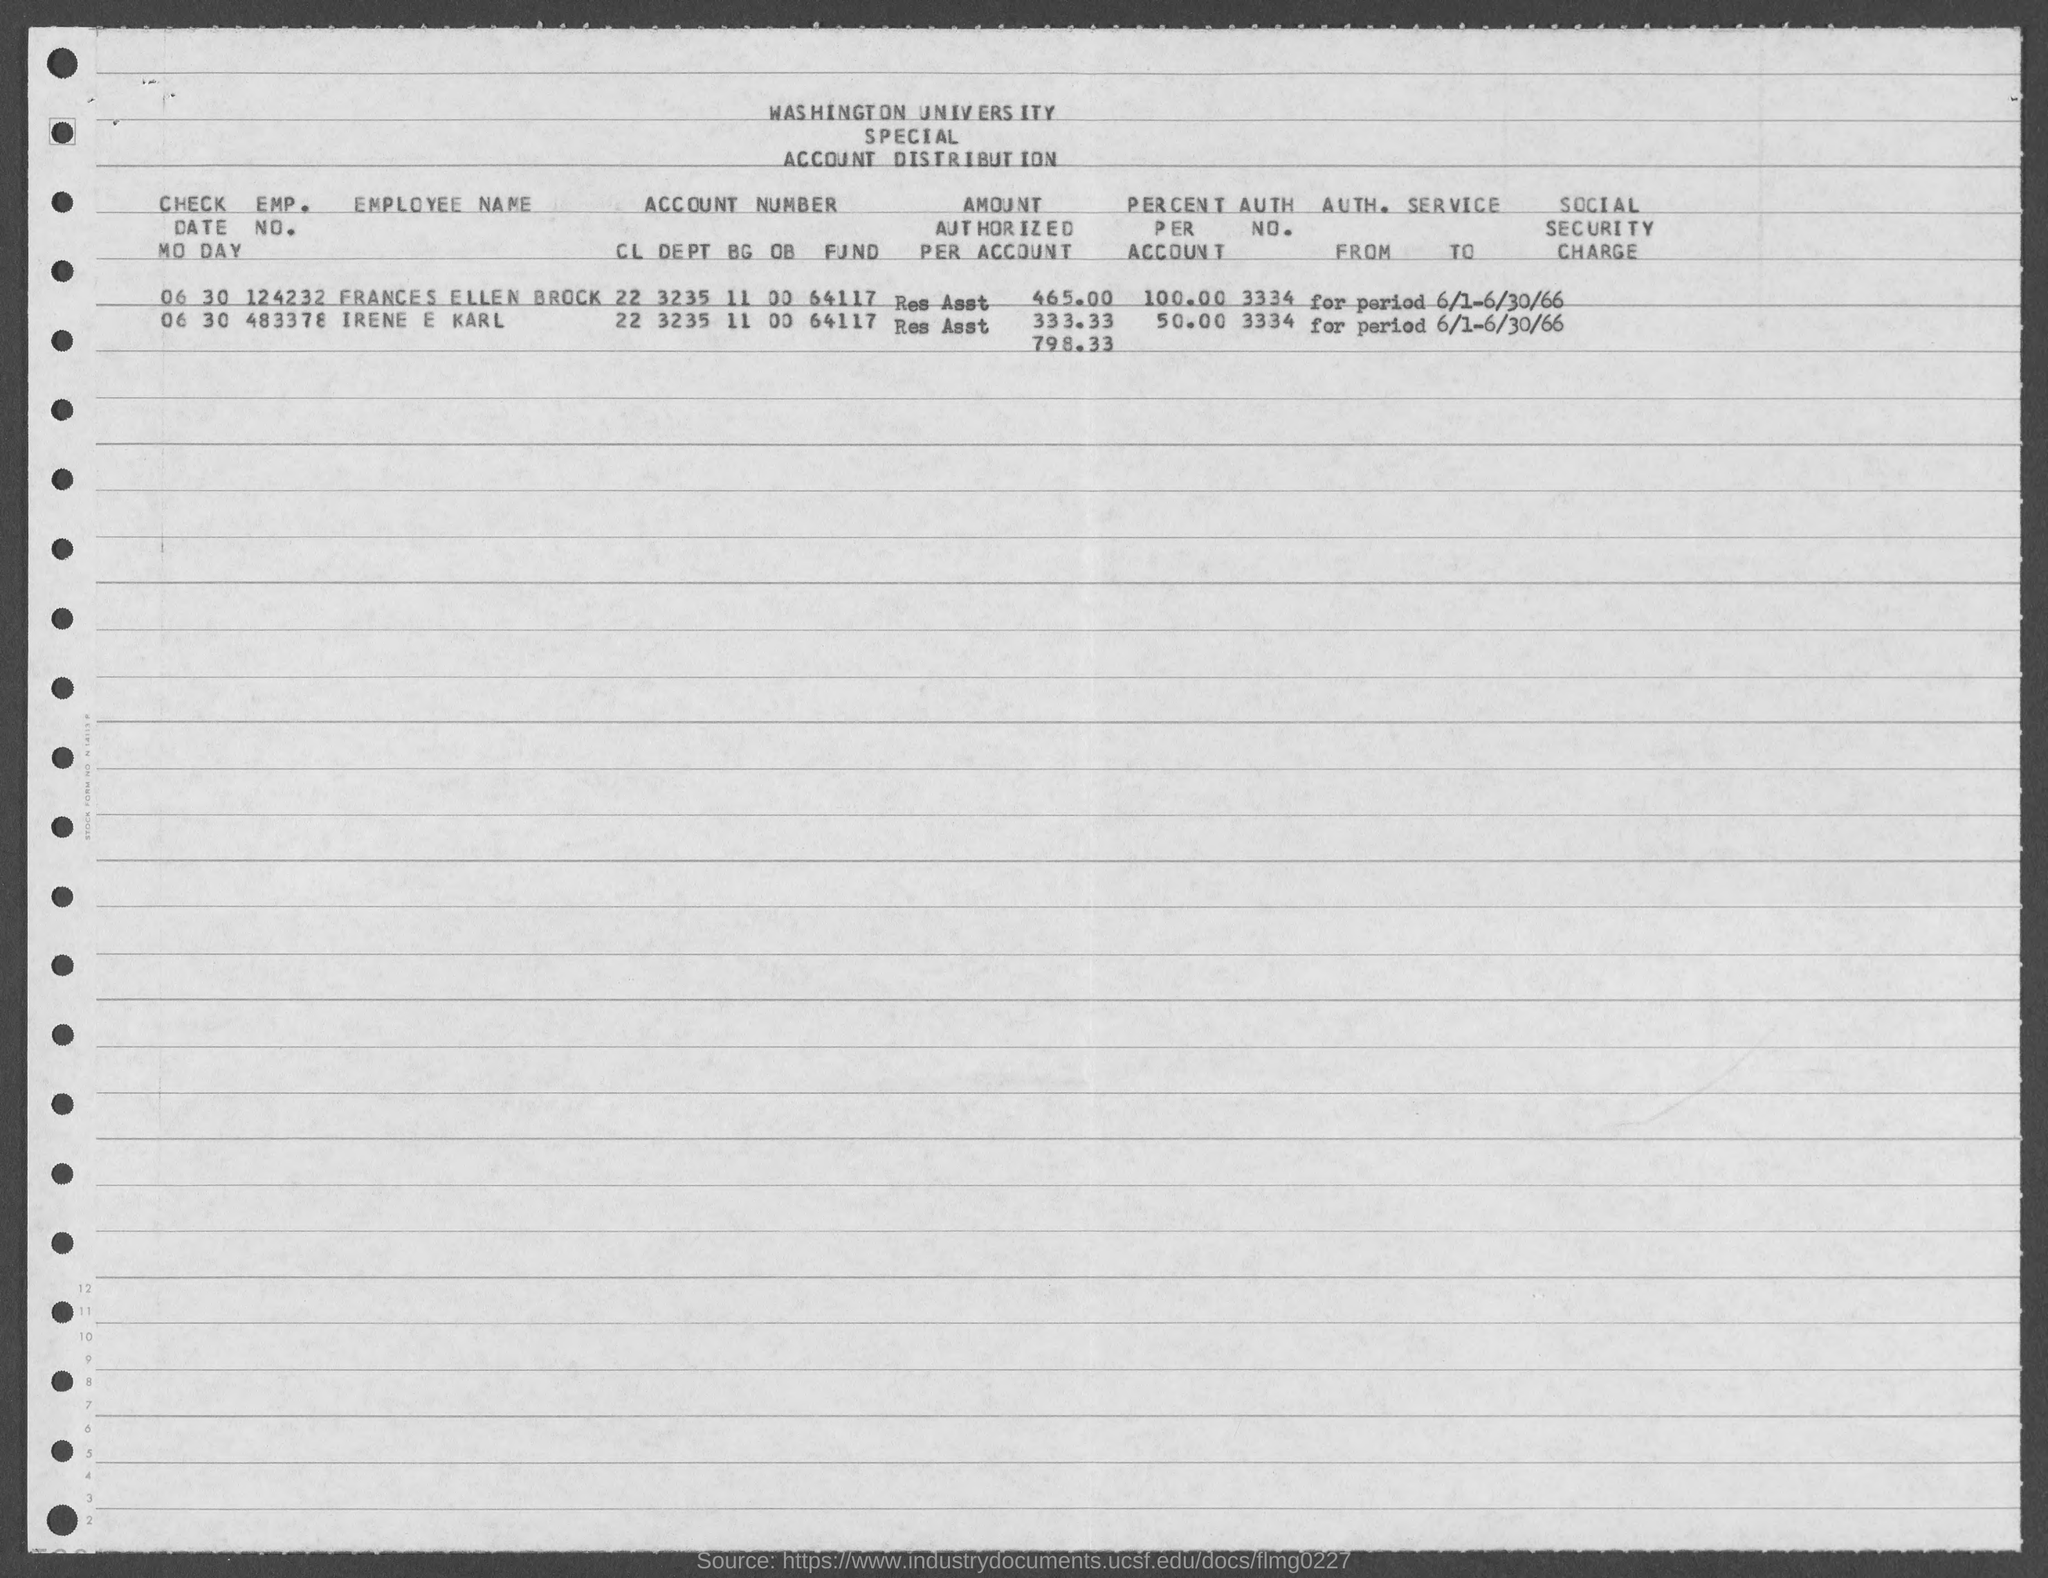What is the employee no of FRANCES ELLEN BROCK?
Make the answer very short. 124232. Who has the Employee no 483378?
Make the answer very short. IRENE E KARL. 